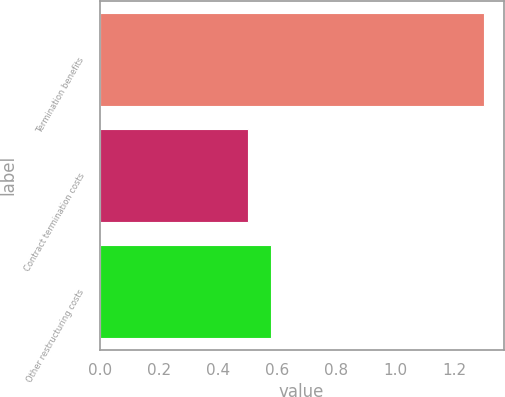Convert chart to OTSL. <chart><loc_0><loc_0><loc_500><loc_500><bar_chart><fcel>Termination benefits<fcel>Contract termination costs<fcel>Other restructuring costs<nl><fcel>1.3<fcel>0.5<fcel>0.58<nl></chart> 